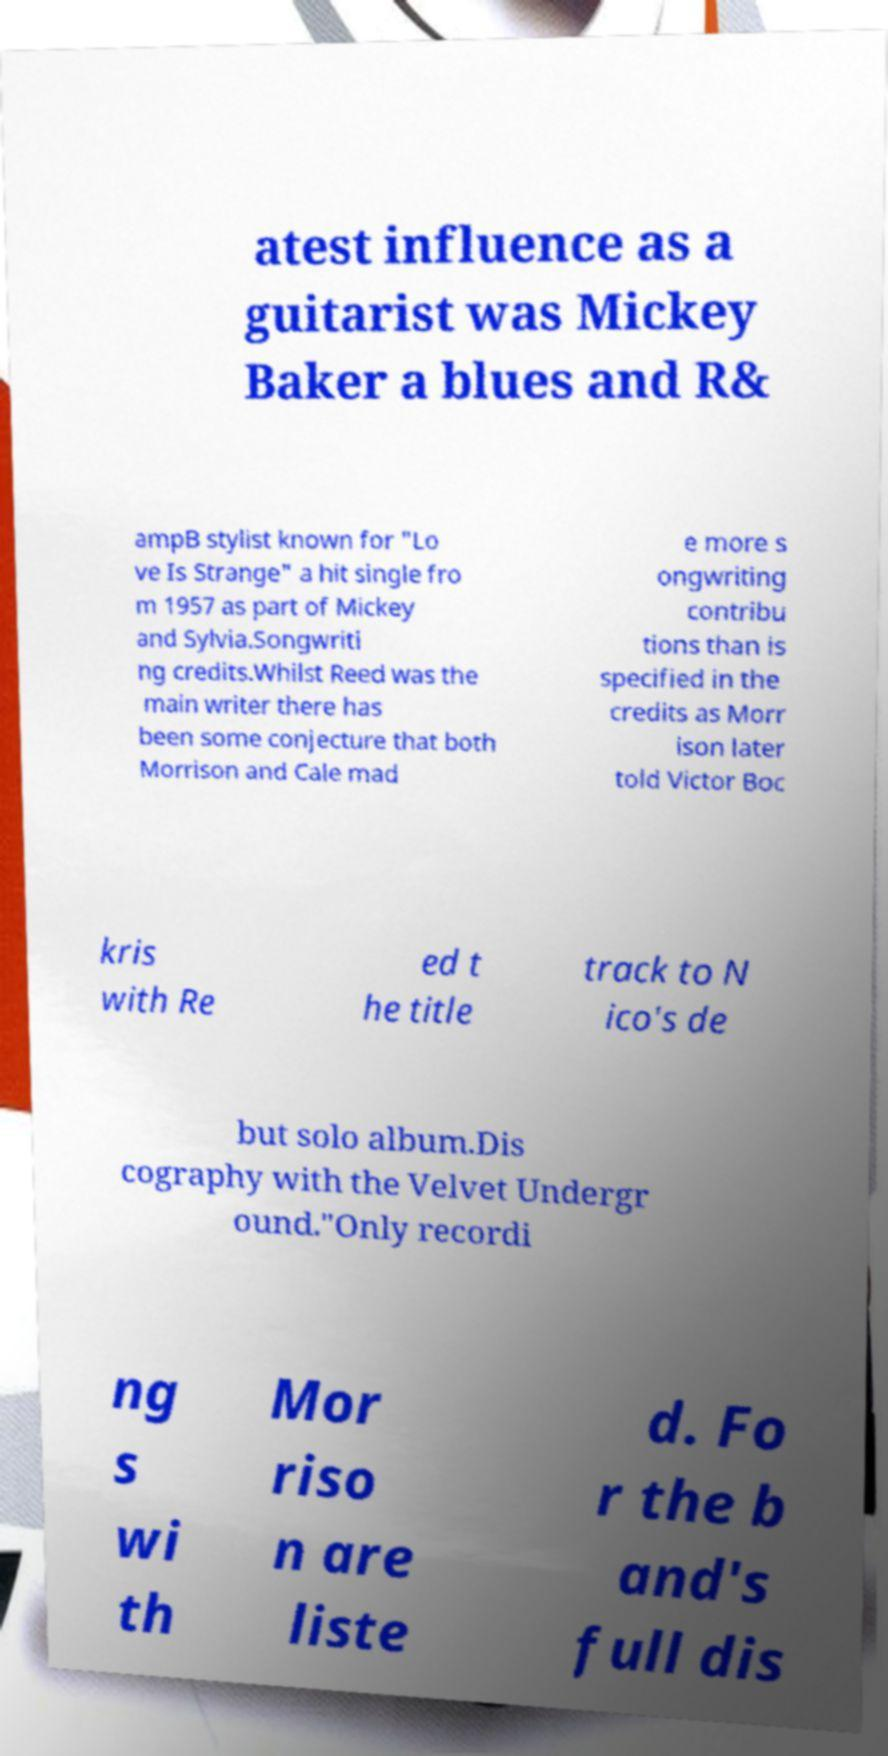What messages or text are displayed in this image? I need them in a readable, typed format. atest influence as a guitarist was Mickey Baker a blues and R& ampB stylist known for "Lo ve Is Strange" a hit single fro m 1957 as part of Mickey and Sylvia.Songwriti ng credits.Whilst Reed was the main writer there has been some conjecture that both Morrison and Cale mad e more s ongwriting contribu tions than is specified in the credits as Morr ison later told Victor Boc kris with Re ed t he title track to N ico's de but solo album.Dis cography with the Velvet Undergr ound."Only recordi ng s wi th Mor riso n are liste d. Fo r the b and's full dis 